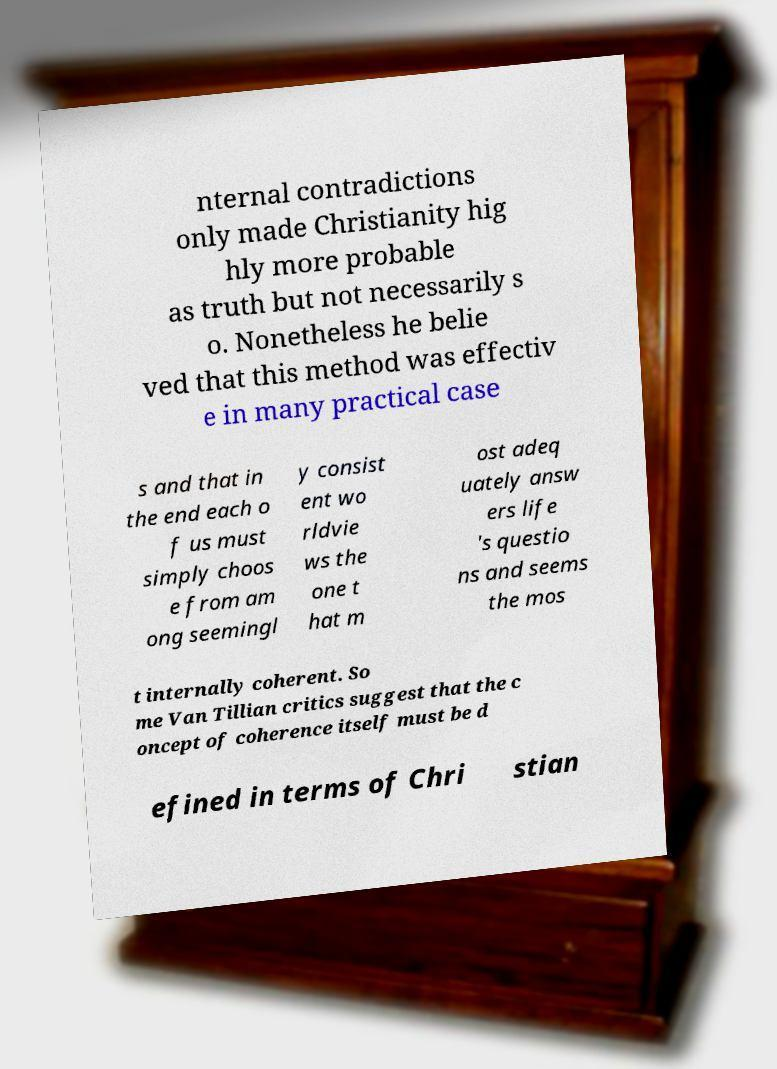Could you assist in decoding the text presented in this image and type it out clearly? nternal contradictions only made Christianity hig hly more probable as truth but not necessarily s o. Nonetheless he belie ved that this method was effectiv e in many practical case s and that in the end each o f us must simply choos e from am ong seemingl y consist ent wo rldvie ws the one t hat m ost adeq uately answ ers life 's questio ns and seems the mos t internally coherent. So me Van Tillian critics suggest that the c oncept of coherence itself must be d efined in terms of Chri stian 